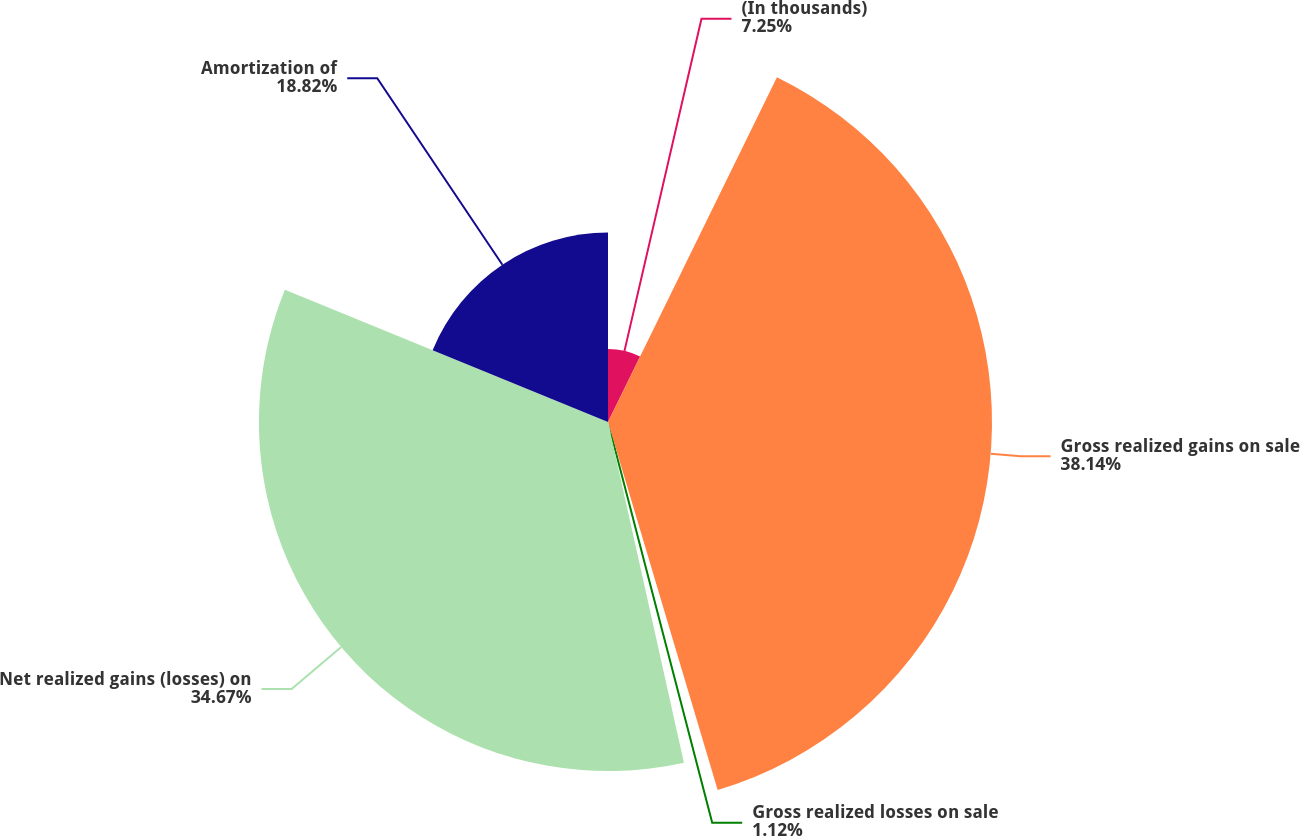Convert chart. <chart><loc_0><loc_0><loc_500><loc_500><pie_chart><fcel>(In thousands)<fcel>Gross realized gains on sale<fcel>Gross realized losses on sale<fcel>Net realized gains (losses) on<fcel>Amortization of<nl><fcel>7.25%<fcel>38.14%<fcel>1.12%<fcel>34.67%<fcel>18.82%<nl></chart> 